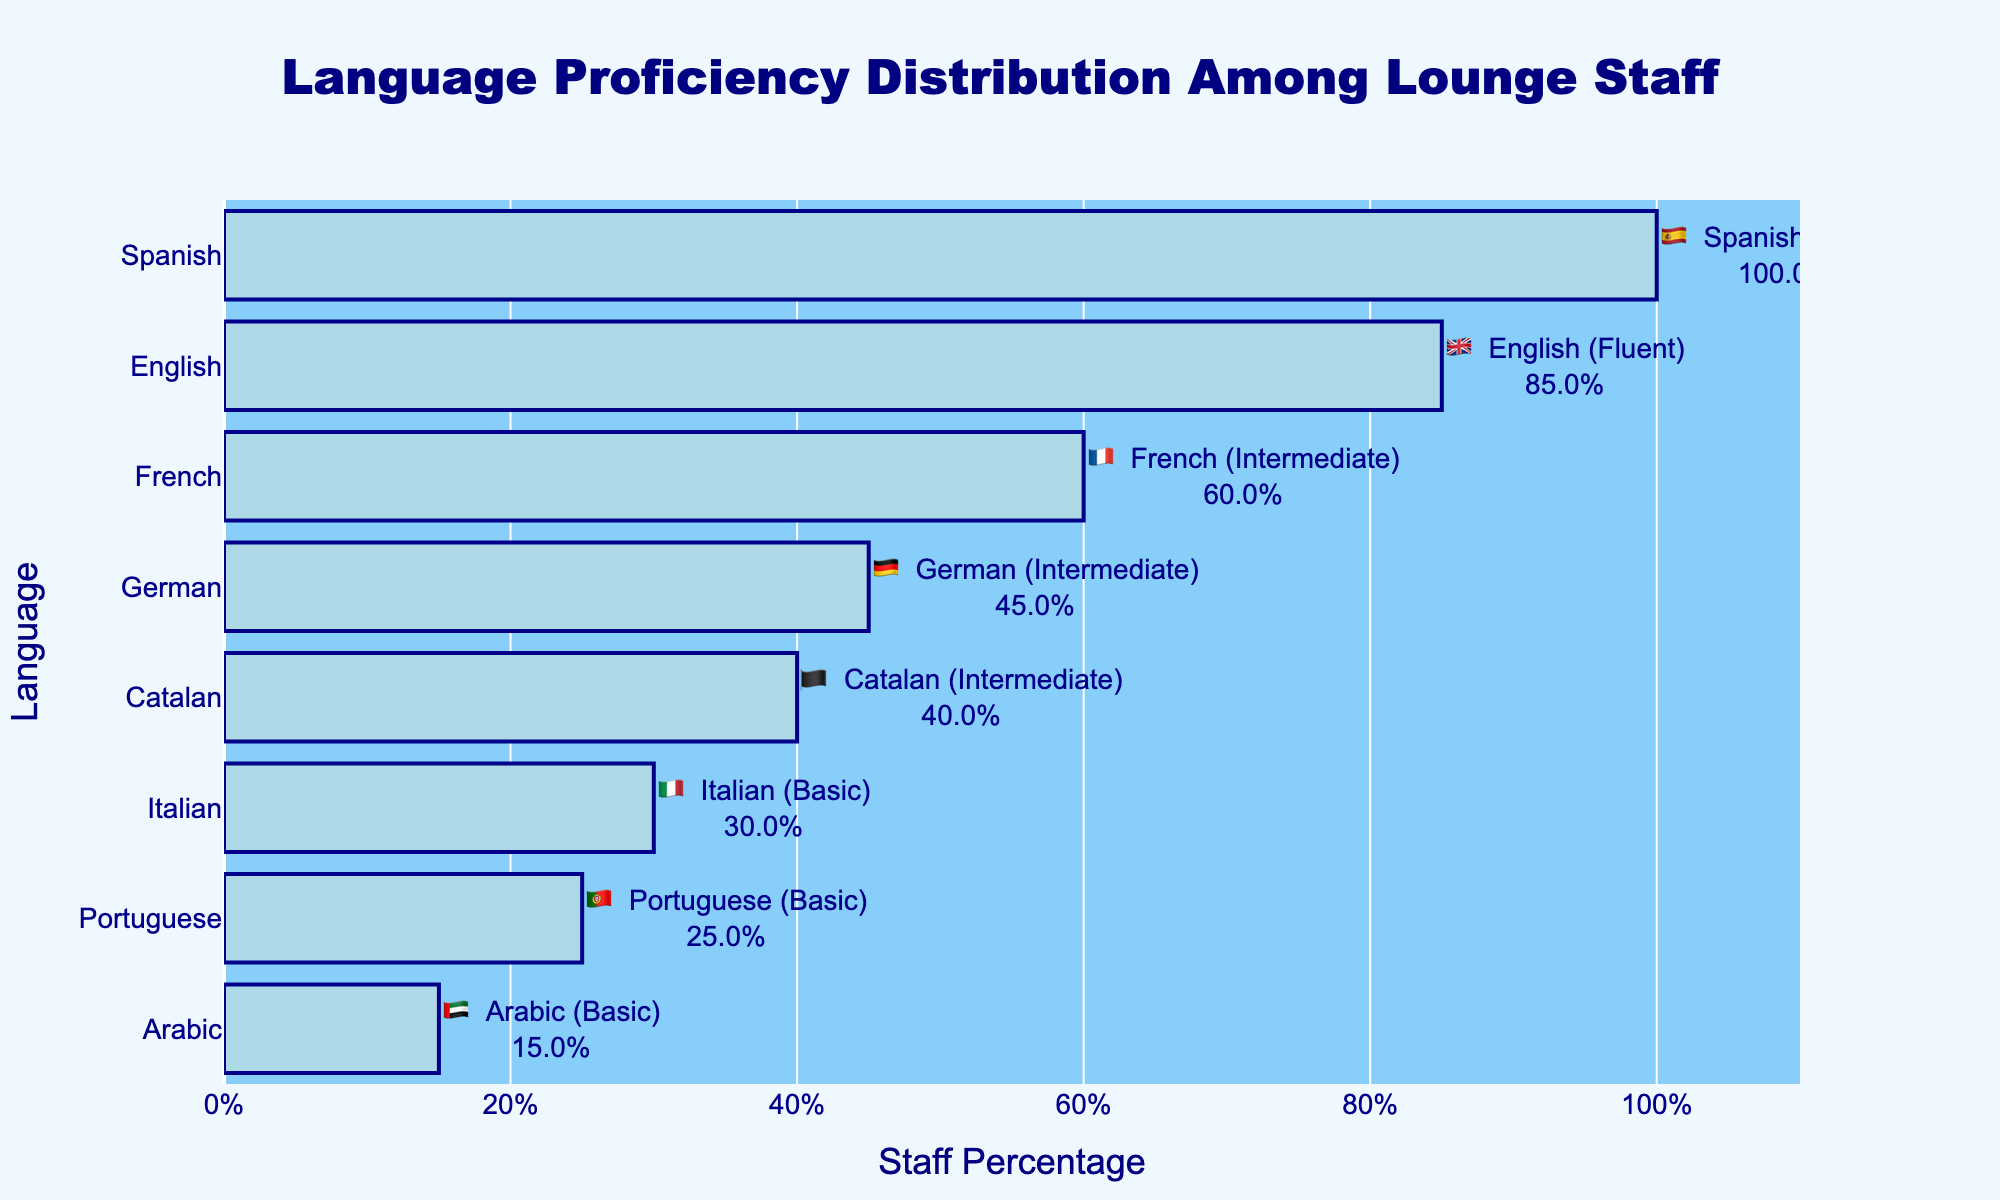What's the title of the chart? The title is usually found at the top of the chart and is meant to provide a brief description of what the chart illustrates. The title in this chart reads "Language Proficiency Distribution Among Lounge Staff."
Answer: Language Proficiency Distribution Among Lounge Staff What is the staff percentage for the Italian language proficiency? To find the staff percentage for Italian, look for the bar corresponding to the Italian flag 🇮🇹 in the chart. The percentage is displayed next to the bar.
Answer: 30% How many languages have a staff percentage of 40% or higher? Count the bars in the chart that have a staff percentage of 40% or more. The languages that meet this criteria are Spanish, English, French, Catalan, and German. That's 5 languages.
Answer: 5 Which languages have a staff percentage less than 50%? Examine the bars that fall below the 50% line. These languages are German, Italian, Portuguese, and Arabic.
Answer: German, Italian, Portuguese, Arabic What is the difference in staff percentage between the language with the highest and the language with the lowest proficiency? Identify the language with the highest staff percentage (Spanish at 100%) and the one with the lowest (Arabic at 15%). Subtract the percentage of the lowest from the highest (100% - 15%).
Answer: 85% Which language has the second highest proficiency among the staff? Look for the bar with the highest value and then identify the next highest bar. The first highest is Spanish, and the second highest is English.
Answer: English Compare the staff percentage of French and Portuguese. Which is higher, and by how much? Locate the bars for French (60%) and Portuguese (25%). Subtract the smaller percentage from the larger one (60% - 25%). French is higher by 35%.
Answer: French by 35% What is the average staff percentage for the three languages with the lowest proficiency? Identify the three lowest percentages, which are Arabic (15%), Portuguese (25%), and Italian (30%). Add these values and divide by 3: (15 + 25 + 30) / 3 = 70 / 3.
Answer: 23.33 What is the median staff percentage of all the languages listed? List all percentages in ascending order: 15%, 25%, 30%, 40%, 45%, 60%, 85%, 100%. The median is the middle value of this ordered list, for an even number of points, take the average of the two central values: (45 + 40) / 2.
Answer: 42.5% How many languages are at an intermediate proficiency level among the staff? Spot the flags with "Intermediate" proficiency tags. These languages are French, German, and Catalan, which are 3 in total.
Answer: 3 